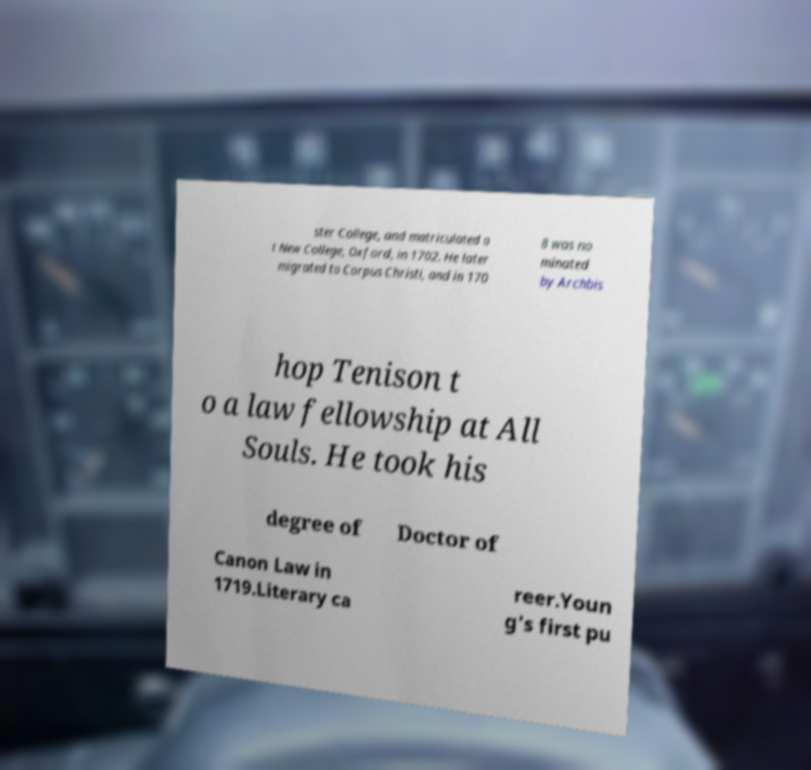Can you read and provide the text displayed in the image?This photo seems to have some interesting text. Can you extract and type it out for me? ster College, and matriculated a t New College, Oxford, in 1702. He later migrated to Corpus Christi, and in 170 8 was no minated by Archbis hop Tenison t o a law fellowship at All Souls. He took his degree of Doctor of Canon Law in 1719.Literary ca reer.Youn g's first pu 